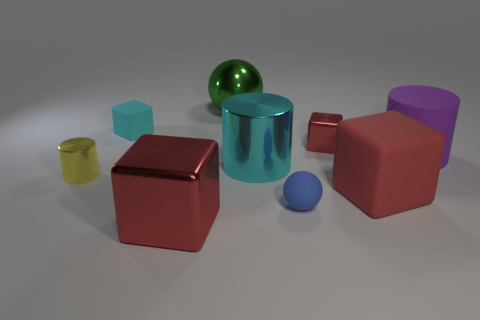The big shiny object that is the same color as the small matte block is what shape?
Make the answer very short. Cylinder. Is there a big rubber block of the same color as the tiny metallic cube?
Offer a very short reply. Yes. What number of other objects are there of the same size as the cyan rubber block?
Provide a short and direct response. 3. Is the number of tiny matte things greater than the number of green metallic spheres?
Give a very brief answer. Yes. What number of rubber cubes are both to the right of the tiny blue thing and behind the small cylinder?
Keep it short and to the point. 0. The red shiny object that is to the right of the sphere in front of the cyan matte object that is to the right of the yellow shiny cylinder is what shape?
Your answer should be compact. Cube. Is there any other thing that is the same shape as the small red metal thing?
Provide a succinct answer. Yes. What number of spheres are large cyan matte objects or large green metallic things?
Provide a succinct answer. 1. Do the big matte object to the left of the large purple object and the tiny shiny cylinder have the same color?
Your answer should be compact. No. There is a block in front of the big red matte block to the right of the small matte object that is behind the tiny yellow cylinder; what is its material?
Provide a short and direct response. Metal. 